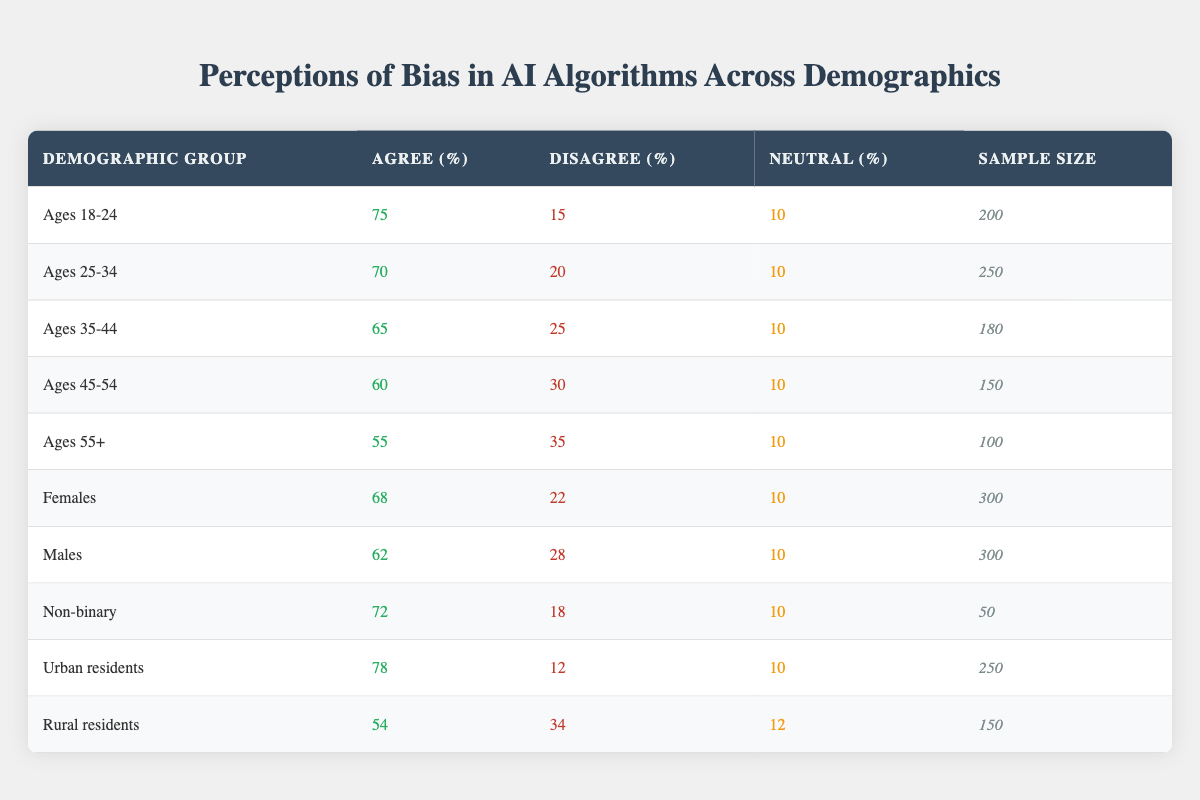What percentage of respondents aged 18-24 agreed that AI algorithms are biased? From the table, the demographic group "Ages 18-24" shows that 75% agreed that AI algorithms are biased.
Answer: 75% Which demographic group had the lowest percentage of agreement on AI bias? In the table, "Ages 55+" shows the lowest agreement on AI bias with 55%.
Answer: Ages 55+ What is the average percentage of agreement across all age demographic groups? To find the average, sum the percentages of agreement in age groups (75 + 70 + 65 + 60 + 55 = 325) and divide by the number of groups (5). Thus, the average is 325/5 = 65%.
Answer: 65% Is it true that more urban residents agree that AI algorithms are biased compared to rural residents? According to the table, urban residents have 78% agreement, while rural residents have 54% agreement. This shows that it is true that more urban residents agree.
Answer: Yes If we combine the sample sizes from all female and male respondents, what is the total sample size? The sample size for females is 300, and for males, it is also 300. Adding these gives us 300 + 300 = 600.
Answer: 600 What percentage of non-binary respondents disagreed with the perception of bias in AI algorithms? The non-binary demographic group shows that 18% disagreed with the perception of bias in AI algorithms.
Answer: 18% Which demographic group shows the highest percentage of disagreement with the perception of bias in AI algorithms? The "Ages 55+" demographic shows the highest disagreement with 35%.
Answer: Ages 55+ What is the difference in agreement percentage between the "Ages 18-24" and "Non-binary" demographic groups? The agreement percentage for "Ages 18-24" is 75%, and for "Non-binary" it's 72%. The difference is 75 - 72 = 3%.
Answer: 3% How many respondents were in the demographic group "Ages 35-44" who disagreed with the idea of bias in AI algorithms? According to the table, the "Ages 35-44" group had 25% disagreement. With a sample size of 180, the number of respondents who disagreed is (25/100) * 180 = 45.
Answer: 45 